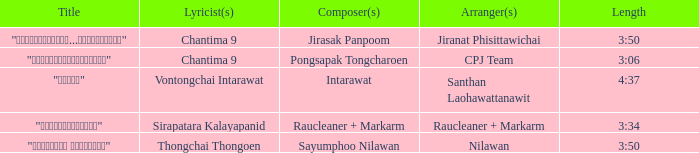Who was responsible for organizing the music for the song featuring sirapatara kalayapanid as the songwriter? Raucleaner + Markarm. 